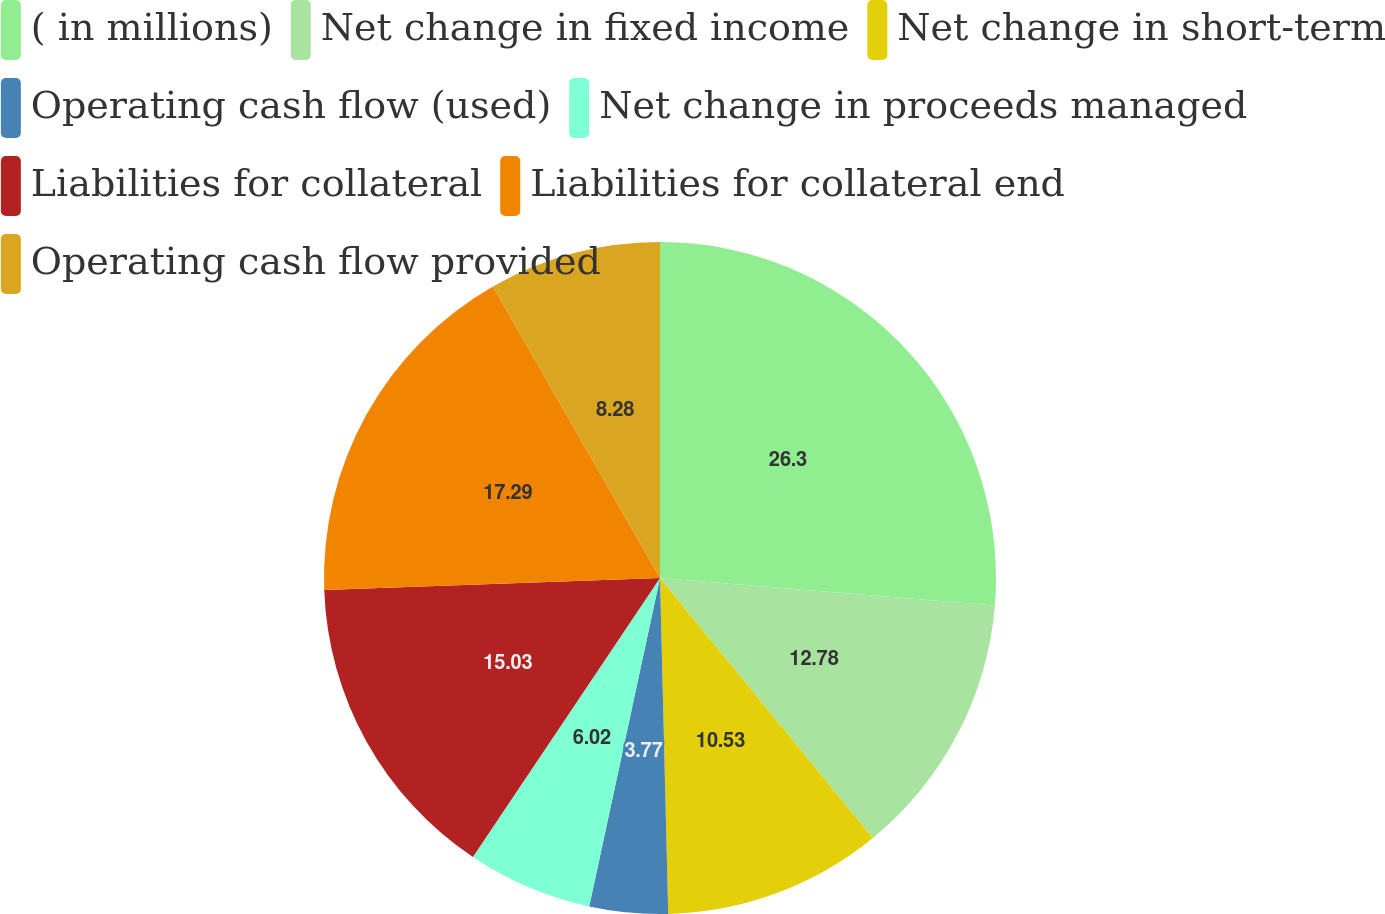Convert chart to OTSL. <chart><loc_0><loc_0><loc_500><loc_500><pie_chart><fcel>( in millions)<fcel>Net change in fixed income<fcel>Net change in short-term<fcel>Operating cash flow (used)<fcel>Net change in proceeds managed<fcel>Liabilities for collateral<fcel>Liabilities for collateral end<fcel>Operating cash flow provided<nl><fcel>26.3%<fcel>12.78%<fcel>10.53%<fcel>3.77%<fcel>6.02%<fcel>15.03%<fcel>17.29%<fcel>8.28%<nl></chart> 